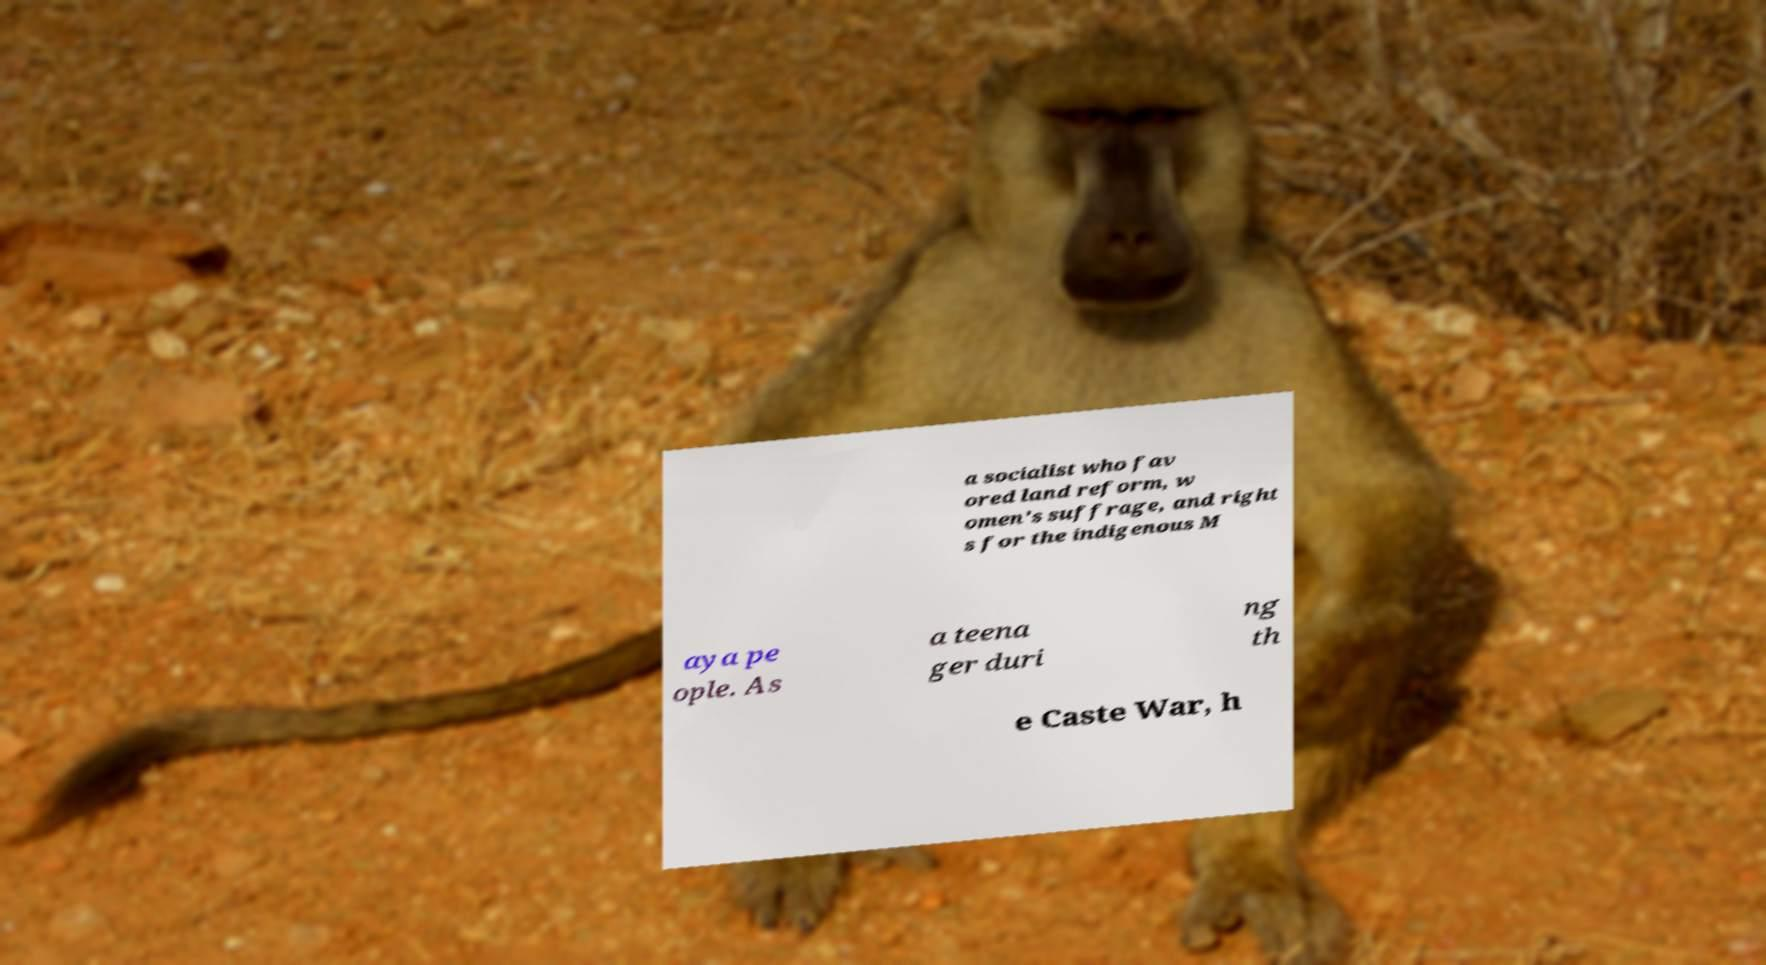Could you assist in decoding the text presented in this image and type it out clearly? a socialist who fav ored land reform, w omen's suffrage, and right s for the indigenous M aya pe ople. As a teena ger duri ng th e Caste War, h 